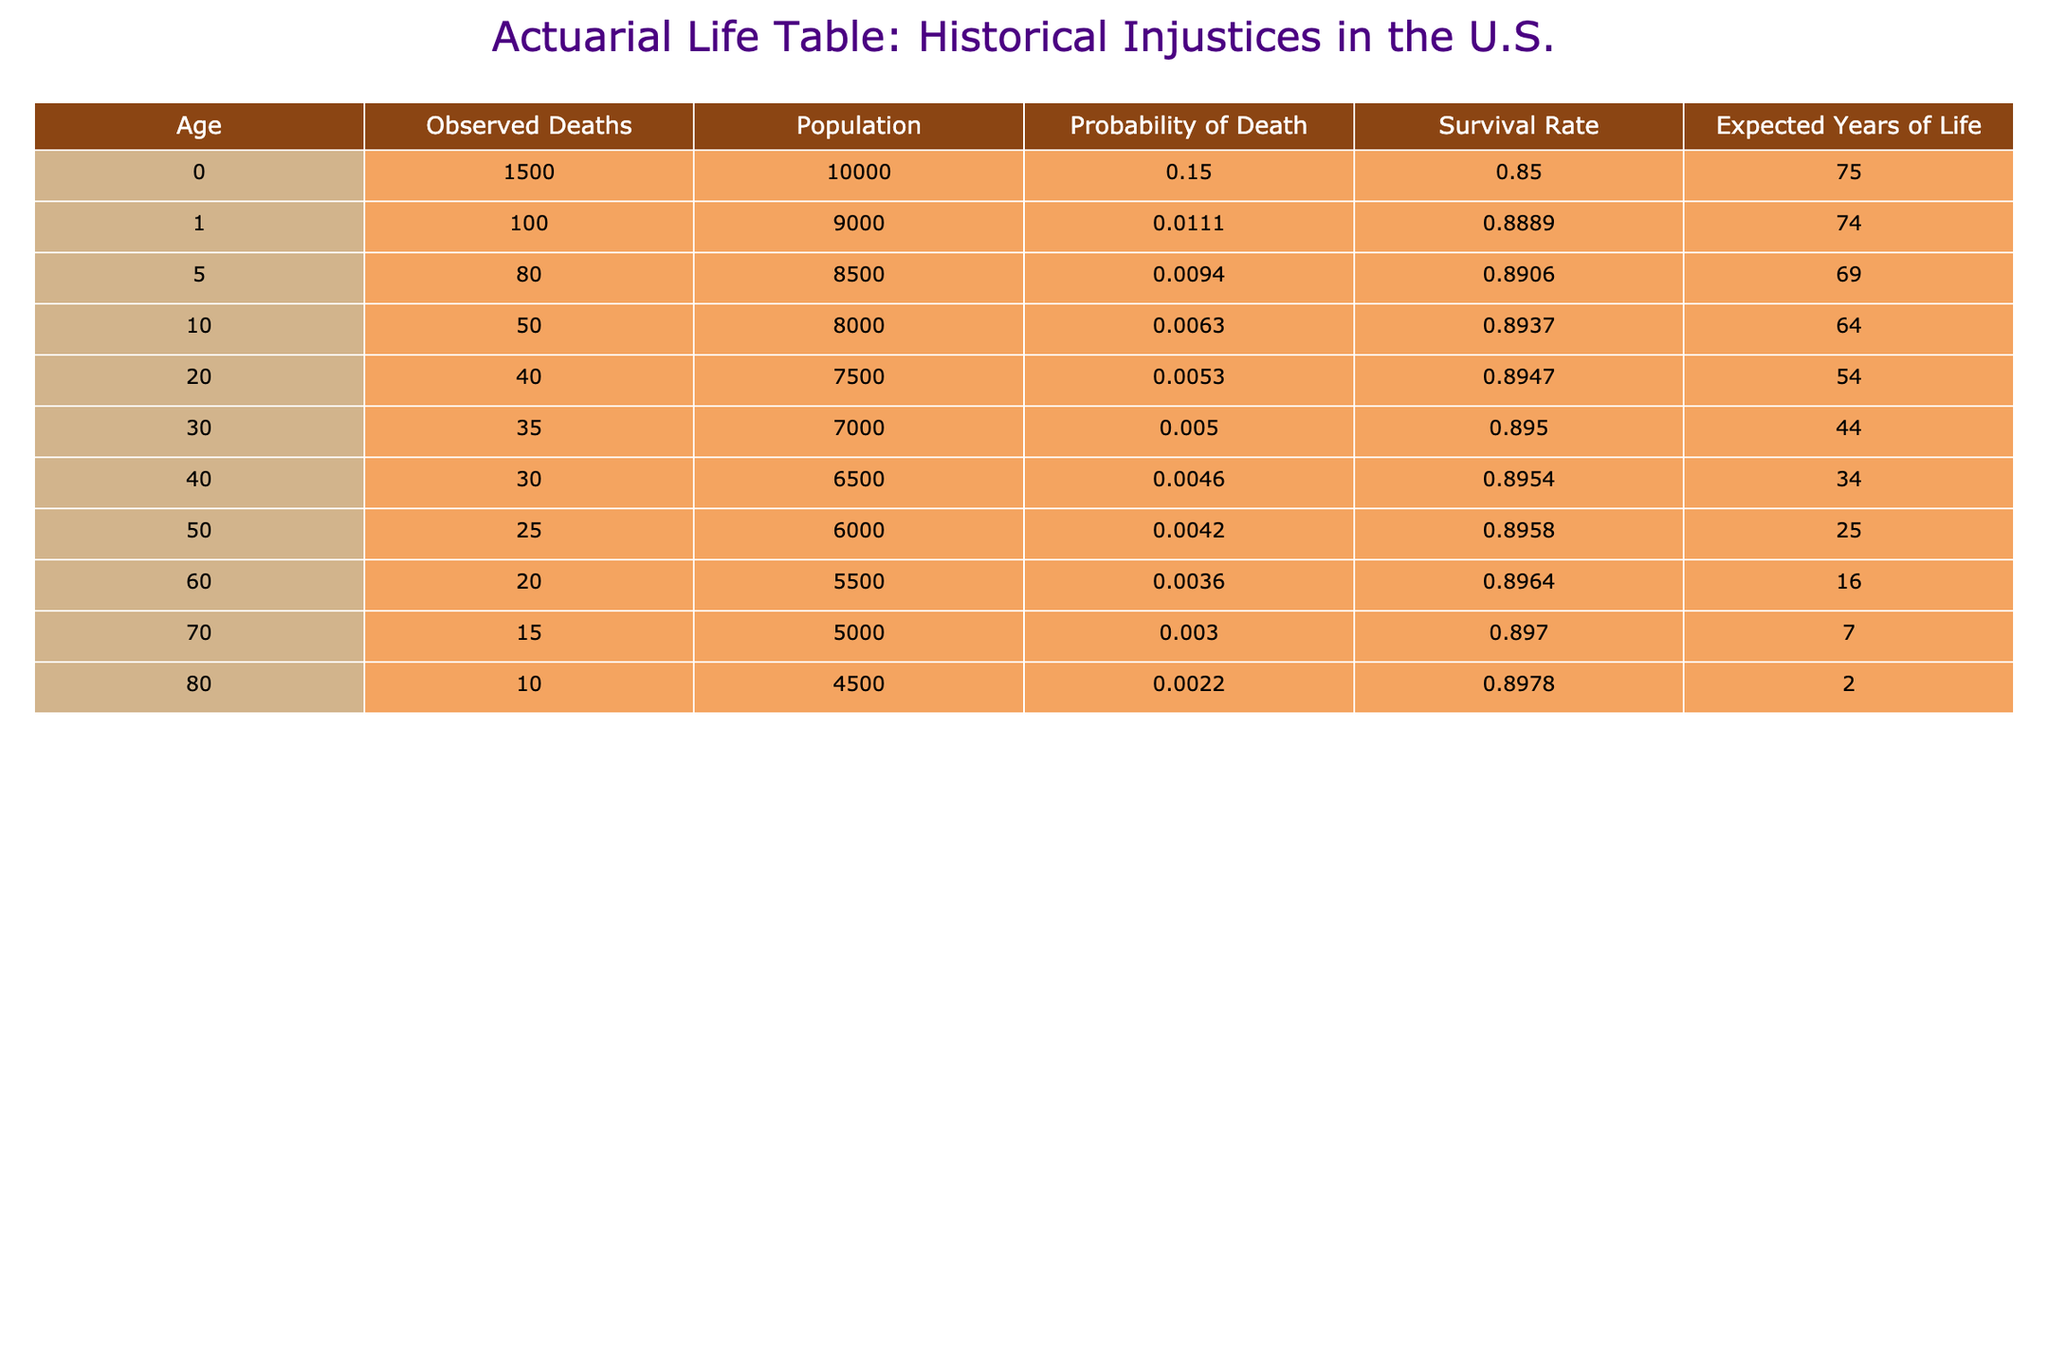What is the probability of death for individuals at age 0? Referring to the table, the probability of death for individuals at age 0 is directly listed under the "Probability of Death" column. For age 0, this value is 0.15.
Answer: 0.15 What is the expected years of life for individuals who are 30 years old? The expected years of life for individuals at age 30 is directly listed in the "Expected Years of Life" column. For age 30, this value is 44.
Answer: 44 How many observed deaths occurred for individuals aged 50? The "Observed Deaths" column indicates that for individuals aged 50, there were 25 observed deaths.
Answer: 25 What is the total expected years of life for individuals aged 0, 1, and 5? To find the total expected years of life for these ages, we sum the "Expected Years of Life" values: 75 (age 0) + 74 (age 1) + 69 (age 5) = 218.
Answer: 218 Is the survival rate higher for age 60 compared to age 70? Looking at the "Survival Rate" column, the survival rate for age 60 is 0.8964, while for age 70 it is 0.897. Since 0.897 is greater than 0.8964, the survival rate for age 70 is indeed higher.
Answer: Yes What is the difference in the number of observed deaths between individuals aged 80 and those aged 20? To find the difference, we subtract the observed deaths for age 20 (40) from those for age 80 (10): 10 - 40 = -30. This indicates there were 30 more observed deaths for age 20 than for age 80.
Answer: 30 What is the average probability of death for all ages listed in the table? First, we sum the probabilities of death for all ages: 0.15 + 0.0111 + 0.0094 + 0.0063 + 0.0053 + 0.005 + 0.0046 + 0.0042 + 0.0036 + 0.003 + 0.0022 = 0.2047. There are 11 ages, so the average is 0.2047 / 11 ≈ 0.0186.
Answer: 0.0186 What percentage of the population aged 40 has survived by the time they reach that age? The survival rate for individuals aged 40 is provided as 0.8954. To express this as a percentage, we multiply by 100: 0.8954 * 100 = 89.54%.
Answer: 89.54% Calculate the total observed deaths for all ages combined. To find the total observed deaths, we sum all the values in the "Observed Deaths" column: 1500 + 100 + 80 + 50 + 40 + 35 + 30 + 25 + 20 + 15 + 10 = 1915.
Answer: 1915 